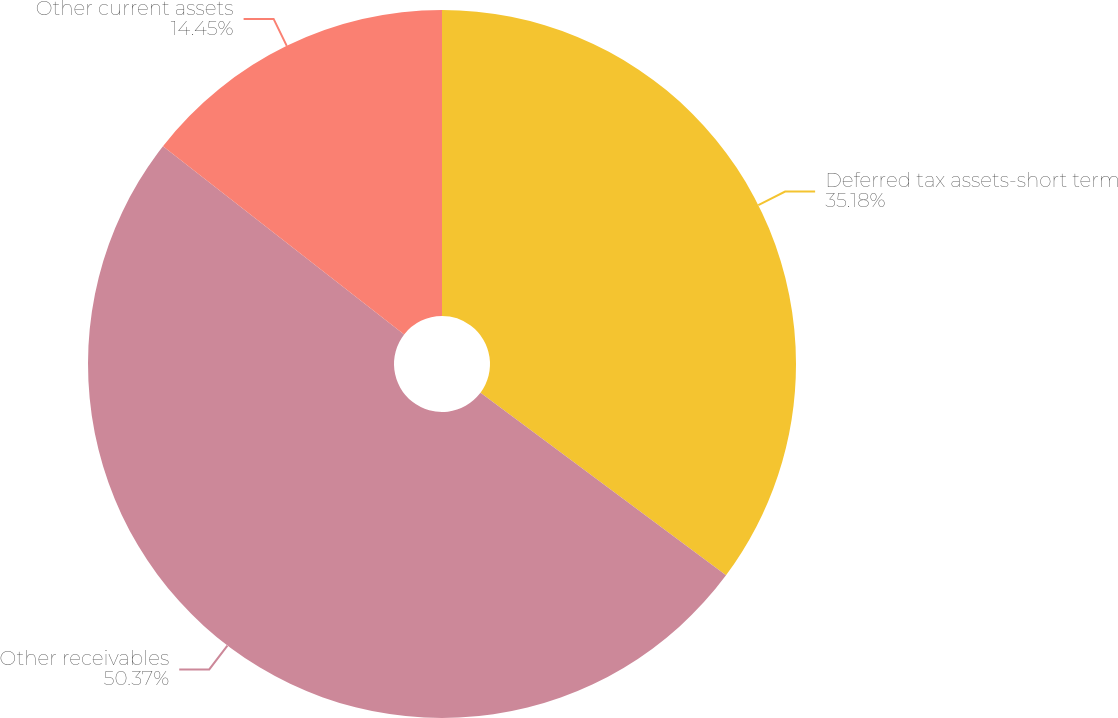Convert chart to OTSL. <chart><loc_0><loc_0><loc_500><loc_500><pie_chart><fcel>Deferred tax assets-short term<fcel>Other receivables<fcel>Other current assets<nl><fcel>35.18%<fcel>50.37%<fcel>14.45%<nl></chart> 